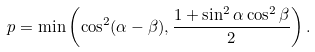Convert formula to latex. <formula><loc_0><loc_0><loc_500><loc_500>p = \min \left ( \cos ^ { 2 } ( \alpha - \beta ) , \frac { 1 + \sin ^ { 2 } \alpha \cos ^ { 2 } \beta } { 2 } \right ) .</formula> 